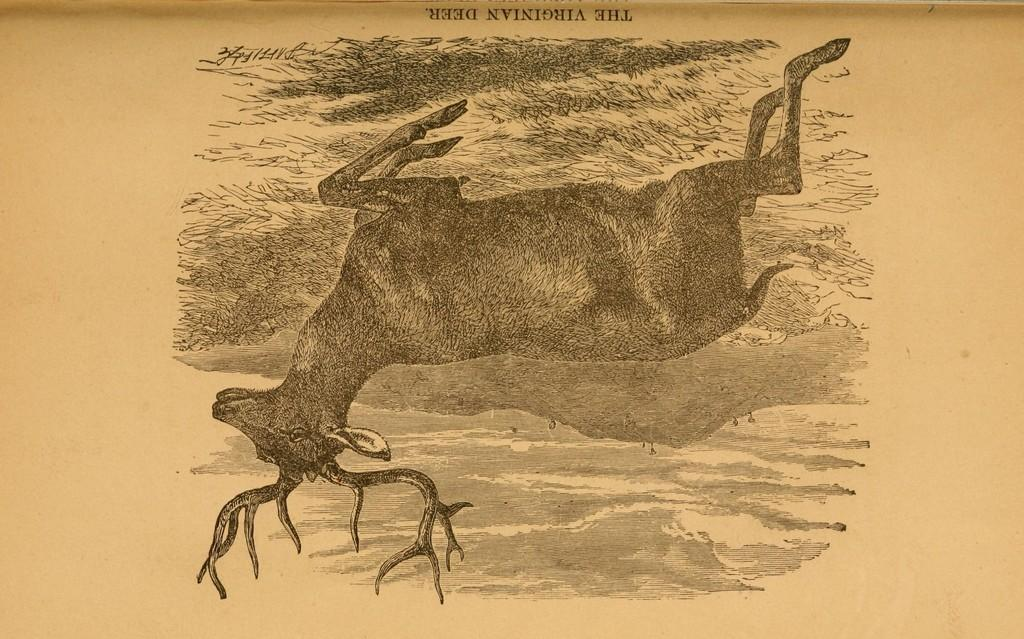What is depicted in the image? There is a sketch of a deer in the image. What type of train can be seen passing through the alley in the image? There is no train or alley present in the image; it features a sketch of a deer. How many holes are visible in the deer's body in the image? There are no holes visible in the deer's body in the image; it is a sketch of a deer without any holes. 